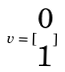Convert formula to latex. <formula><loc_0><loc_0><loc_500><loc_500>v = [ \begin{matrix} 0 \\ 1 \end{matrix} ]</formula> 